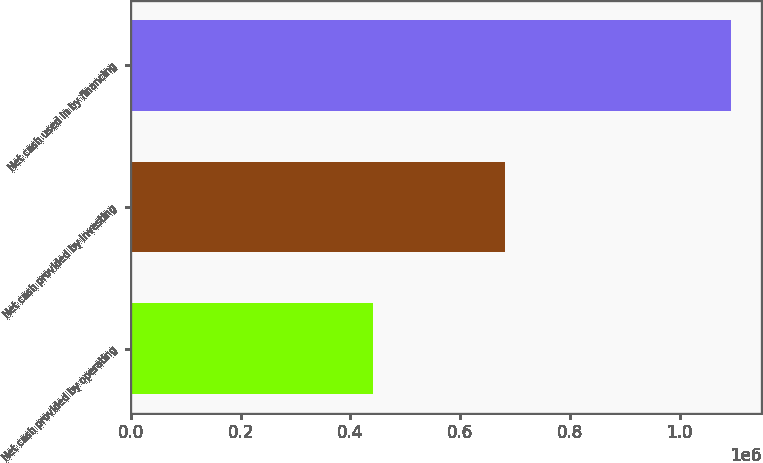Convert chart to OTSL. <chart><loc_0><loc_0><loc_500><loc_500><bar_chart><fcel>Net cash provided by operating<fcel>Net cash provided by investing<fcel>Net cash used in by financing<nl><fcel>441537<fcel>681662<fcel>1.09411e+06<nl></chart> 